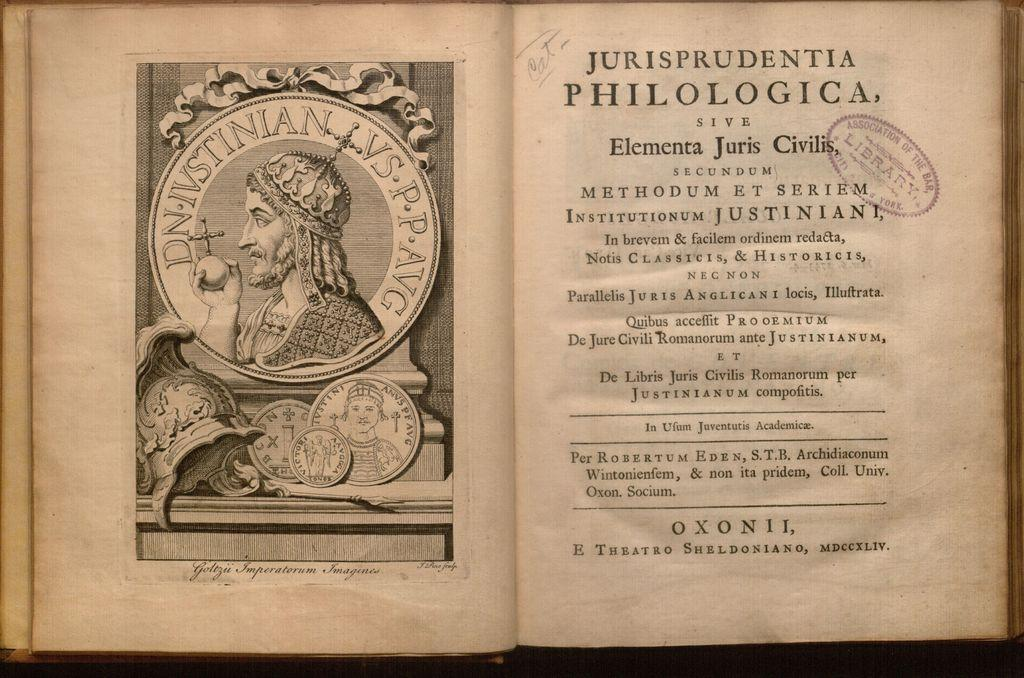<image>
Relay a brief, clear account of the picture shown. a book is opened to a page saying jurisprudentia at the top 